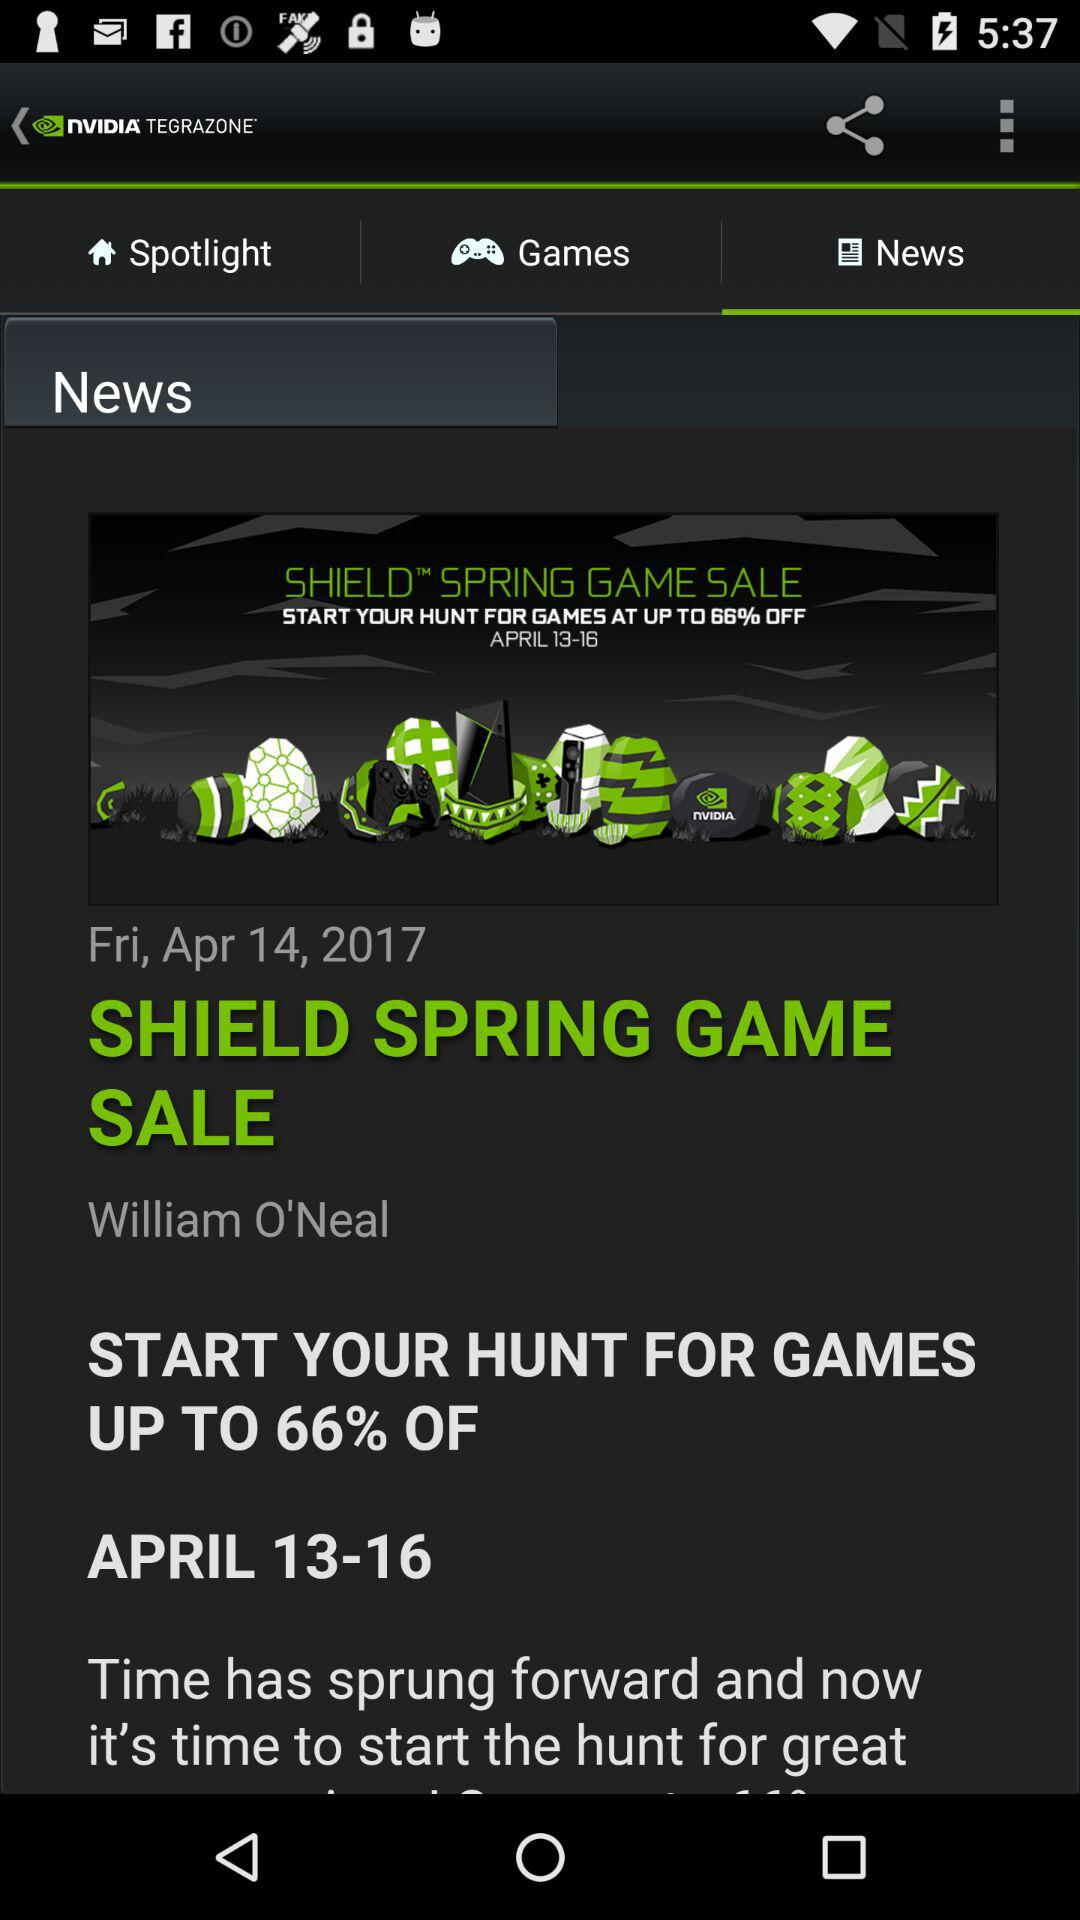How much is the off percentage for games? The off percentage for games is 66. 